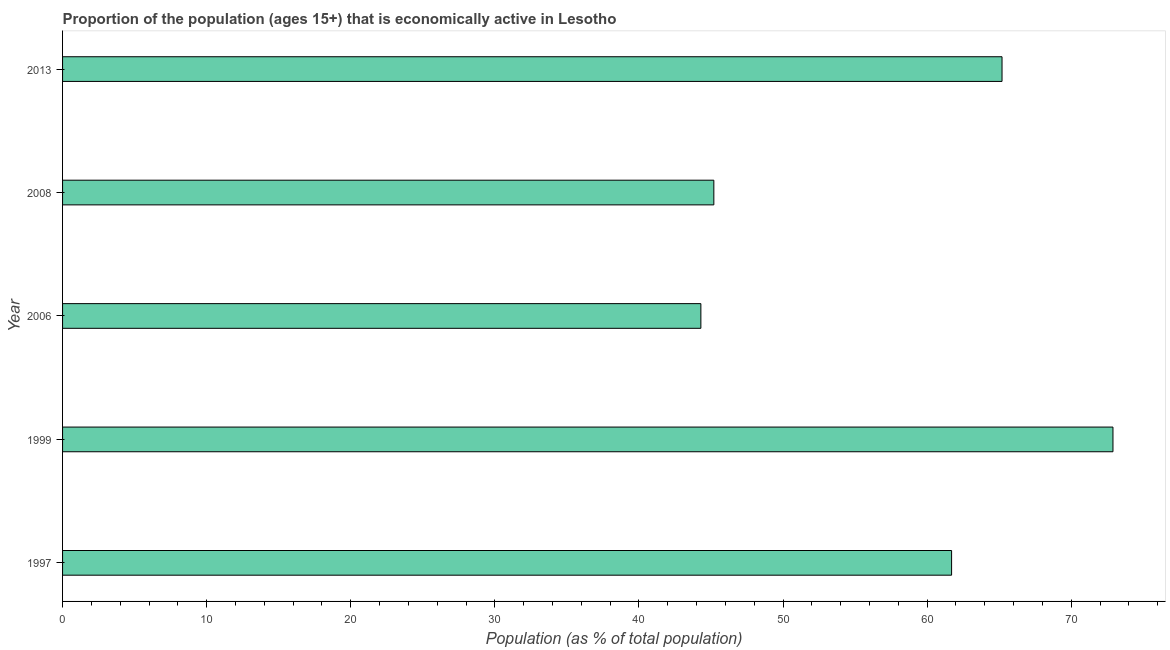Does the graph contain any zero values?
Provide a short and direct response. No. What is the title of the graph?
Your answer should be compact. Proportion of the population (ages 15+) that is economically active in Lesotho. What is the label or title of the X-axis?
Your answer should be very brief. Population (as % of total population). What is the label or title of the Y-axis?
Provide a succinct answer. Year. What is the percentage of economically active population in 2006?
Offer a very short reply. 44.3. Across all years, what is the maximum percentage of economically active population?
Your response must be concise. 72.9. Across all years, what is the minimum percentage of economically active population?
Your answer should be very brief. 44.3. In which year was the percentage of economically active population maximum?
Give a very brief answer. 1999. In which year was the percentage of economically active population minimum?
Keep it short and to the point. 2006. What is the sum of the percentage of economically active population?
Ensure brevity in your answer.  289.3. What is the difference between the percentage of economically active population in 1999 and 2008?
Keep it short and to the point. 27.7. What is the average percentage of economically active population per year?
Ensure brevity in your answer.  57.86. What is the median percentage of economically active population?
Give a very brief answer. 61.7. Do a majority of the years between 2008 and 1997 (inclusive) have percentage of economically active population greater than 22 %?
Offer a very short reply. Yes. What is the ratio of the percentage of economically active population in 1997 to that in 1999?
Provide a short and direct response. 0.85. What is the difference between the highest and the second highest percentage of economically active population?
Give a very brief answer. 7.7. What is the difference between the highest and the lowest percentage of economically active population?
Your answer should be compact. 28.6. What is the Population (as % of total population) of 1997?
Offer a very short reply. 61.7. What is the Population (as % of total population) of 1999?
Your response must be concise. 72.9. What is the Population (as % of total population) of 2006?
Your response must be concise. 44.3. What is the Population (as % of total population) in 2008?
Make the answer very short. 45.2. What is the Population (as % of total population) of 2013?
Provide a short and direct response. 65.2. What is the difference between the Population (as % of total population) in 1997 and 2013?
Offer a very short reply. -3.5. What is the difference between the Population (as % of total population) in 1999 and 2006?
Your response must be concise. 28.6. What is the difference between the Population (as % of total population) in 1999 and 2008?
Ensure brevity in your answer.  27.7. What is the difference between the Population (as % of total population) in 1999 and 2013?
Your answer should be compact. 7.7. What is the difference between the Population (as % of total population) in 2006 and 2013?
Ensure brevity in your answer.  -20.9. What is the ratio of the Population (as % of total population) in 1997 to that in 1999?
Provide a succinct answer. 0.85. What is the ratio of the Population (as % of total population) in 1997 to that in 2006?
Provide a short and direct response. 1.39. What is the ratio of the Population (as % of total population) in 1997 to that in 2008?
Your answer should be compact. 1.36. What is the ratio of the Population (as % of total population) in 1997 to that in 2013?
Ensure brevity in your answer.  0.95. What is the ratio of the Population (as % of total population) in 1999 to that in 2006?
Make the answer very short. 1.65. What is the ratio of the Population (as % of total population) in 1999 to that in 2008?
Make the answer very short. 1.61. What is the ratio of the Population (as % of total population) in 1999 to that in 2013?
Your answer should be very brief. 1.12. What is the ratio of the Population (as % of total population) in 2006 to that in 2013?
Give a very brief answer. 0.68. What is the ratio of the Population (as % of total population) in 2008 to that in 2013?
Offer a terse response. 0.69. 